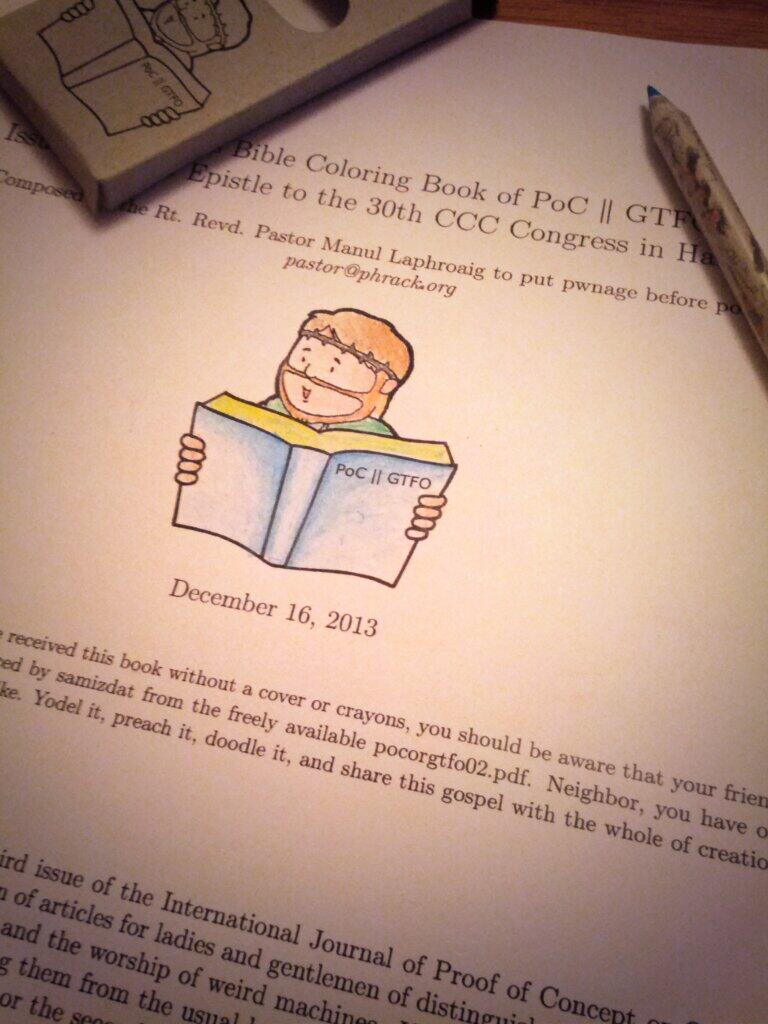<image>
Present a compact description of the photo's key features. a page from a Bible coloring book from December 16, 2013 